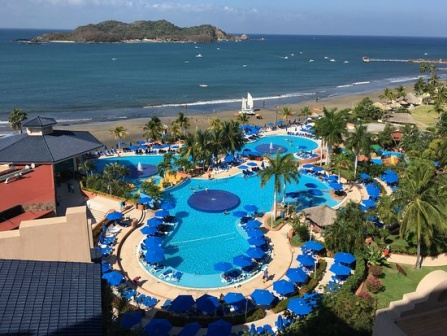Describe the resort's pool area and its amenities in detail. The resort's pool area is an expansive and artfully designed space that serves as the focal point of the complex. The pool itself is an eye-catching, bright blue and shaped like a giant flower, complete with winding curves resembling petals encircling a central circular area. Adjacent to the pool is a large circular deeper section, perfect for swimming laps or just floating leisurely. Surrounding this centerpiece are several palm trees, adding a tropical feel and offering patches of shade amidst the sun-drenched space.

In addition to the pool, numerous amenities enhance the guests' experience. Around the pool, rows of blue lounge chairs are neatly arranged, each paired with blue umbrellas for shade. These areas invite relaxation and provide a perfect spot for enjoying a sunny day while sipping a cool drink. Additionally, there are poolside cabanas for guests seeking a more private and shaded retreat, each providing comfortable seating and a respite from the sun.

The meticulous maintenance of the pool and its surrounding areas further enriches the resort experience. Crystal-clear water continually beams under the sun, and the overall cleanliness and orderliness of the space reflect the resort's dedication to providing a high-quality environment for its guests. 